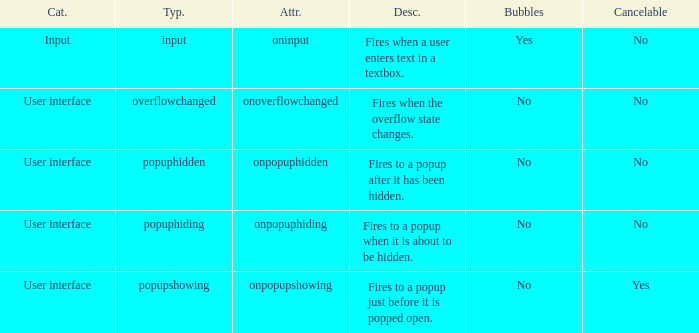What's the bubbles with attribute being onpopuphidden No. 